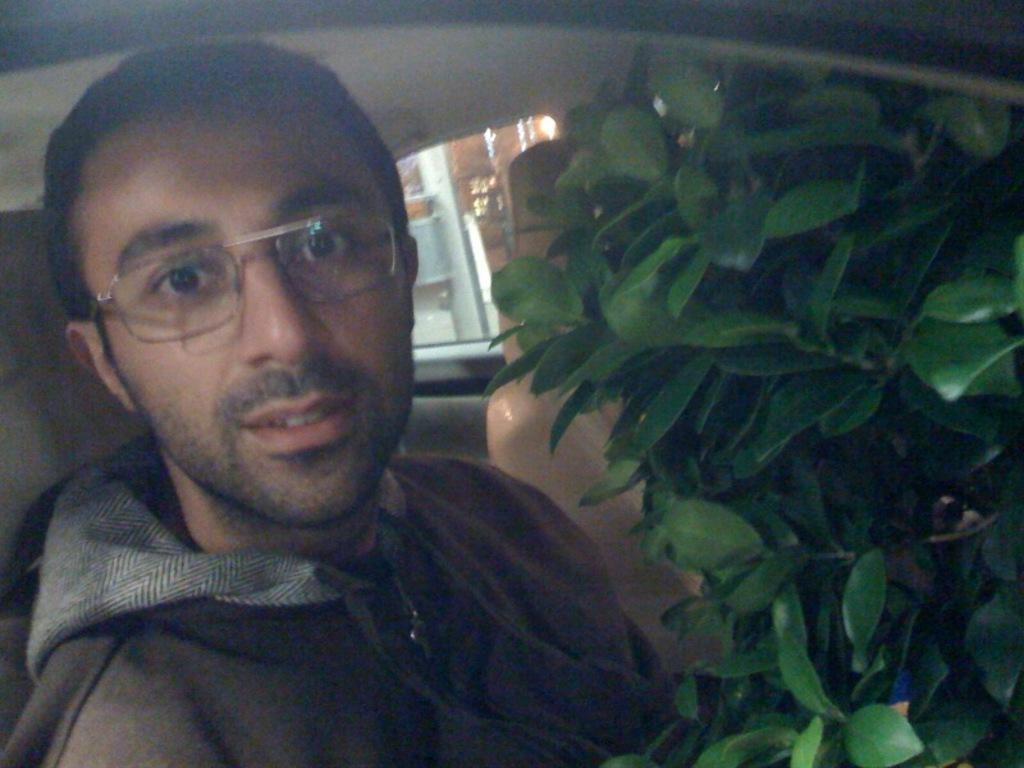Describe this image in one or two sentences. This image is taken in a vehicle. On the right side of the image there is a plant with green leaves. In the middle of the image a man is sitting in the seat. In the background there is a window and a door of a car. 